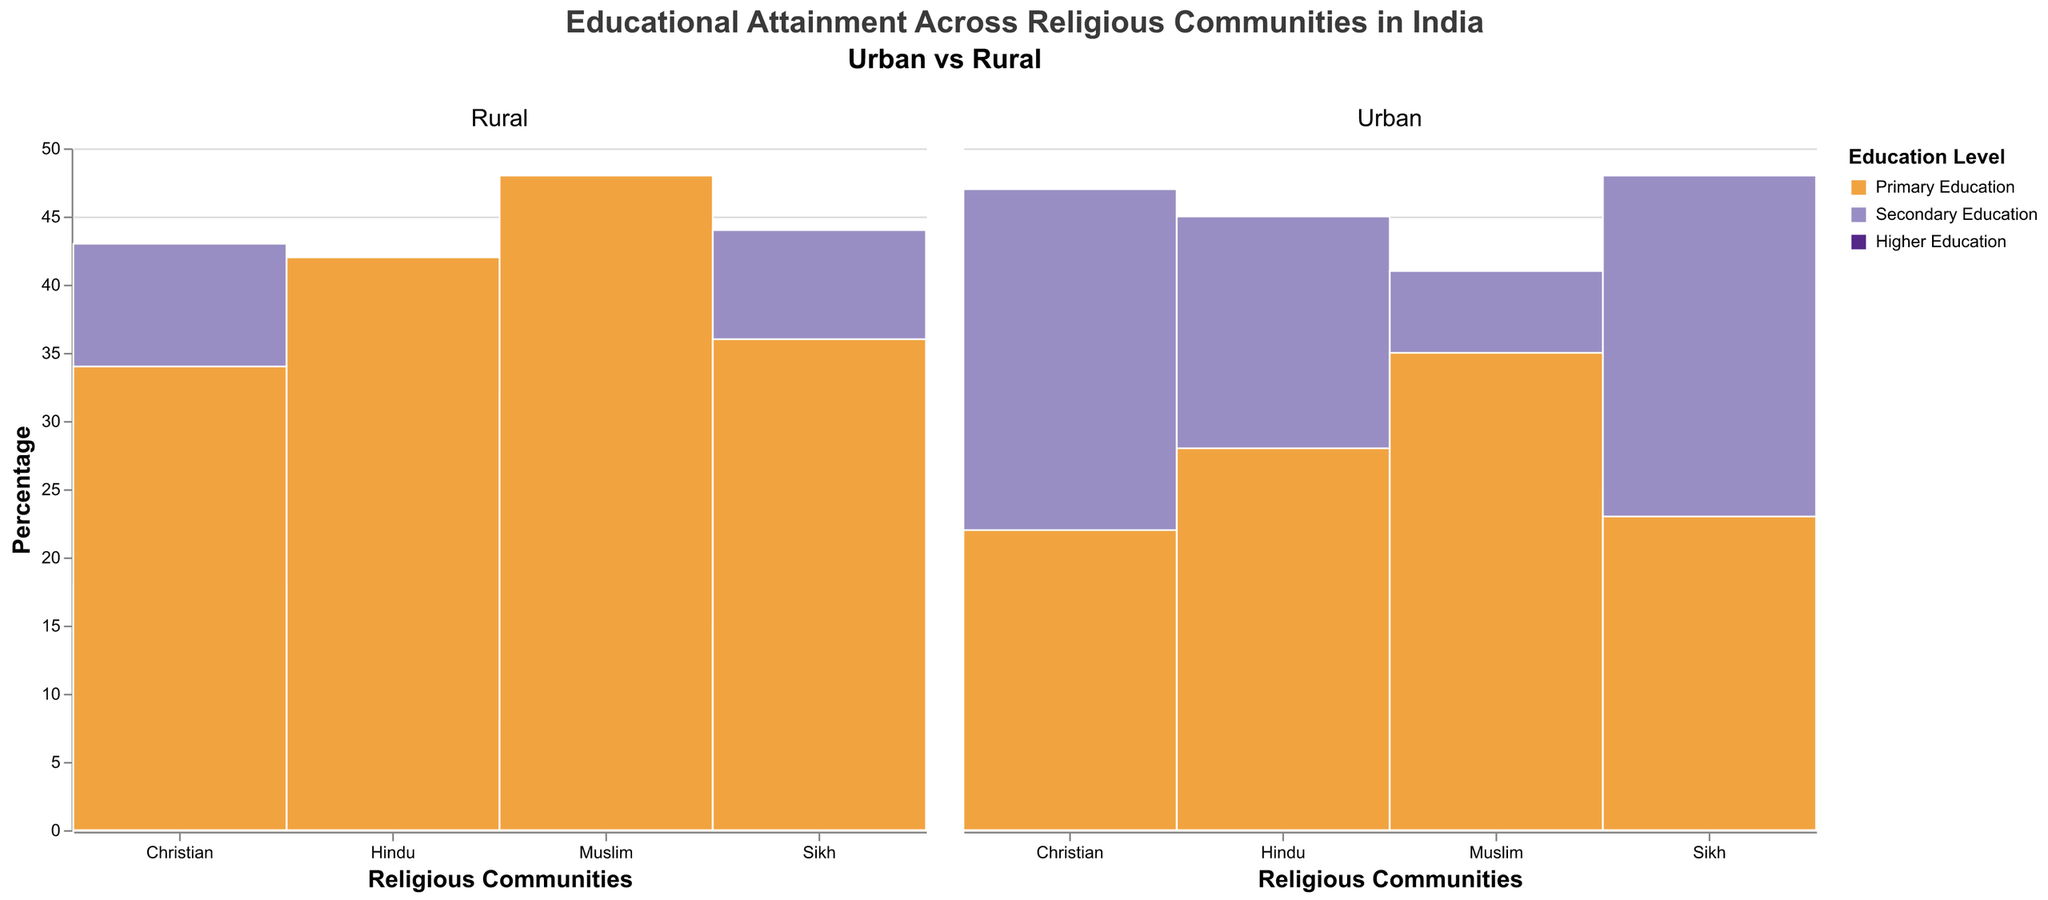How is the educational attainment among Hindu communities different between urban and rural areas? In the urban areas, Hindu communities have higher percentages in Higher Education (22%) and Secondary Education (45%) compared to rural areas, where the percentages are 12% and 38% respectively. Conversely, a greater percentage of Hindus in rural areas have Primary Education (42%) compared to those in urban areas (28%)
Answer: Urban Hindus have higher education levels Which religious community has the highest percentage of Higher Education in urban areas? Looking at the urban area data, Christians have the highest percentage in Higher Education at 28%, followed by Sikhs at 25%, Hindus at 22%, and Muslims at 17%
Answer: Christians In rural areas, which group has the highest percentage of Primary Education? Examining the rural area data, Muslims have the highest percentage in Primary Education at 48%, followed by Hindus at 42%, Sikhs at 36%, and Christians at 34%
Answer: Muslims Compare the Secondary Education attainment between urban and rural areas for Christians. In urban areas, 47% of Christians have Secondary Education, while in rural areas, the percentage is slightly lower at 43%
Answer: Urban: 47%, Rural: 43% Which religious community shows the largest disparity in Higher Education percentages between urban and rural areas? Muslims show the largest disparity with 17% in urban areas and only 8% in rural areas, a difference of 9 percentage points
Answer: Muslims What is the percentage of Sikhs with Secondary Education in rural areas compared to urban areas? Sikhs have a 48% Secondary Education attainment in urban areas and 44% in rural areas
Answer: Urban: 48%, Rural: 44% Which area (urban or rural) has a higher percentage of individuals with Higher Education across all religious communities? Urban areas have higher percentages of individuals with Higher Education across all religious communities when compared to rural areas
Answer: Urban areas Which education level shows the least variability across religious communities in urban areas? In urban areas, Secondary Education shows the least variability with percentages ranging from 41% to 48% among the different religious communities
Answer: Secondary Education Calculate the difference in the percentage of Muslims with Primary Education between rural and urban areas. Muslims have 48% in Primary Education in rural areas and 35% in urban areas. The difference is 48% - 35% = 13%
Answer: 13% Which religious community has the smallest gap in Secondary Education percentages between urban and rural areas? Hindus show the smallest gap with 45% in urban areas and 38% in rural areas, a difference of 7 percentage points
Answer: Hindus 